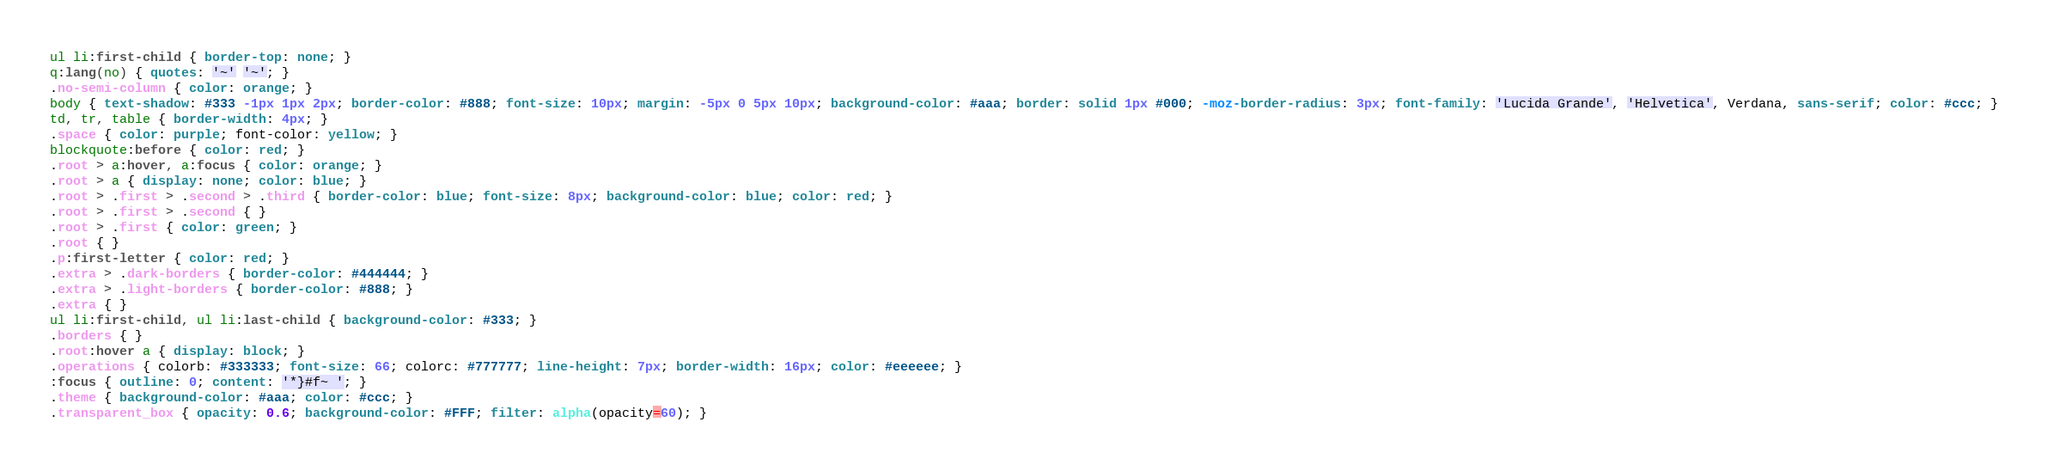<code> <loc_0><loc_0><loc_500><loc_500><_CSS_>ul li:first-child { border-top: none; }
q:lang(no) { quotes: '~' '~'; }
.no-semi-column { color: orange; }
body { text-shadow: #333 -1px 1px 2px; border-color: #888; font-size: 10px; margin: -5px 0 5px 10px; background-color: #aaa; border: solid 1px #000; -moz-border-radius: 3px; font-family: 'Lucida Grande', 'Helvetica', Verdana, sans-serif; color: #ccc; }
td, tr, table { border-width: 4px; }
.space { color: purple; font-color: yellow; }
blockquote:before { color: red; }
.root > a:hover, a:focus { color: orange; }
.root > a { display: none; color: blue; }
.root > .first > .second > .third { border-color: blue; font-size: 8px; background-color: blue; color: red; }
.root > .first > .second { }
.root > .first { color: green; }
.root { }
.p:first-letter { color: red; }
.extra > .dark-borders { border-color: #444444; }
.extra > .light-borders { border-color: #888; }
.extra { }
ul li:first-child, ul li:last-child { background-color: #333; }
.borders { }
.root:hover a { display: block; }
.operations { colorb: #333333; font-size: 66; colorc: #777777; line-height: 7px; border-width: 16px; color: #eeeeee; }
:focus { outline: 0; content: '*}#f~ '; }
.theme { background-color: #aaa; color: #ccc; }
.transparent_box { opacity: 0.6; background-color: #FFF; filter: alpha(opacity=60); }</code> 